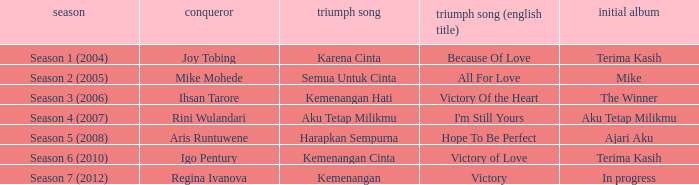Who won with the song kemenangan cinta? Igo Pentury. Parse the full table. {'header': ['season', 'conqueror', 'triumph song', 'triumph song (english title)', 'initial album'], 'rows': [['Season 1 (2004)', 'Joy Tobing', 'Karena Cinta', 'Because Of Love', 'Terima Kasih'], ['Season 2 (2005)', 'Mike Mohede', 'Semua Untuk Cinta', 'All For Love', 'Mike'], ['Season 3 (2006)', 'Ihsan Tarore', 'Kemenangan Hati', 'Victory Of the Heart', 'The Winner'], ['Season 4 (2007)', 'Rini Wulandari', 'Aku Tetap Milikmu', "I'm Still Yours", 'Aku Tetap Milikmu'], ['Season 5 (2008)', 'Aris Runtuwene', 'Harapkan Sempurna', 'Hope To Be Perfect', 'Ajari Aku'], ['Season 6 (2010)', 'Igo Pentury', 'Kemenangan Cinta', 'Victory of Love', 'Terima Kasih'], ['Season 7 (2012)', 'Regina Ivanova', 'Kemenangan', 'Victory', 'In progress']]} 